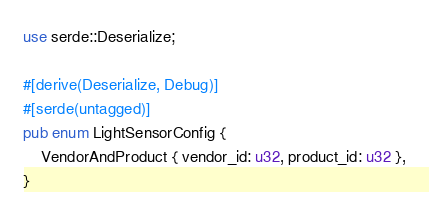<code> <loc_0><loc_0><loc_500><loc_500><_Rust_>use serde::Deserialize;

#[derive(Deserialize, Debug)]
#[serde(untagged)]
pub enum LightSensorConfig {
    VendorAndProduct { vendor_id: u32, product_id: u32 },
}
</code> 